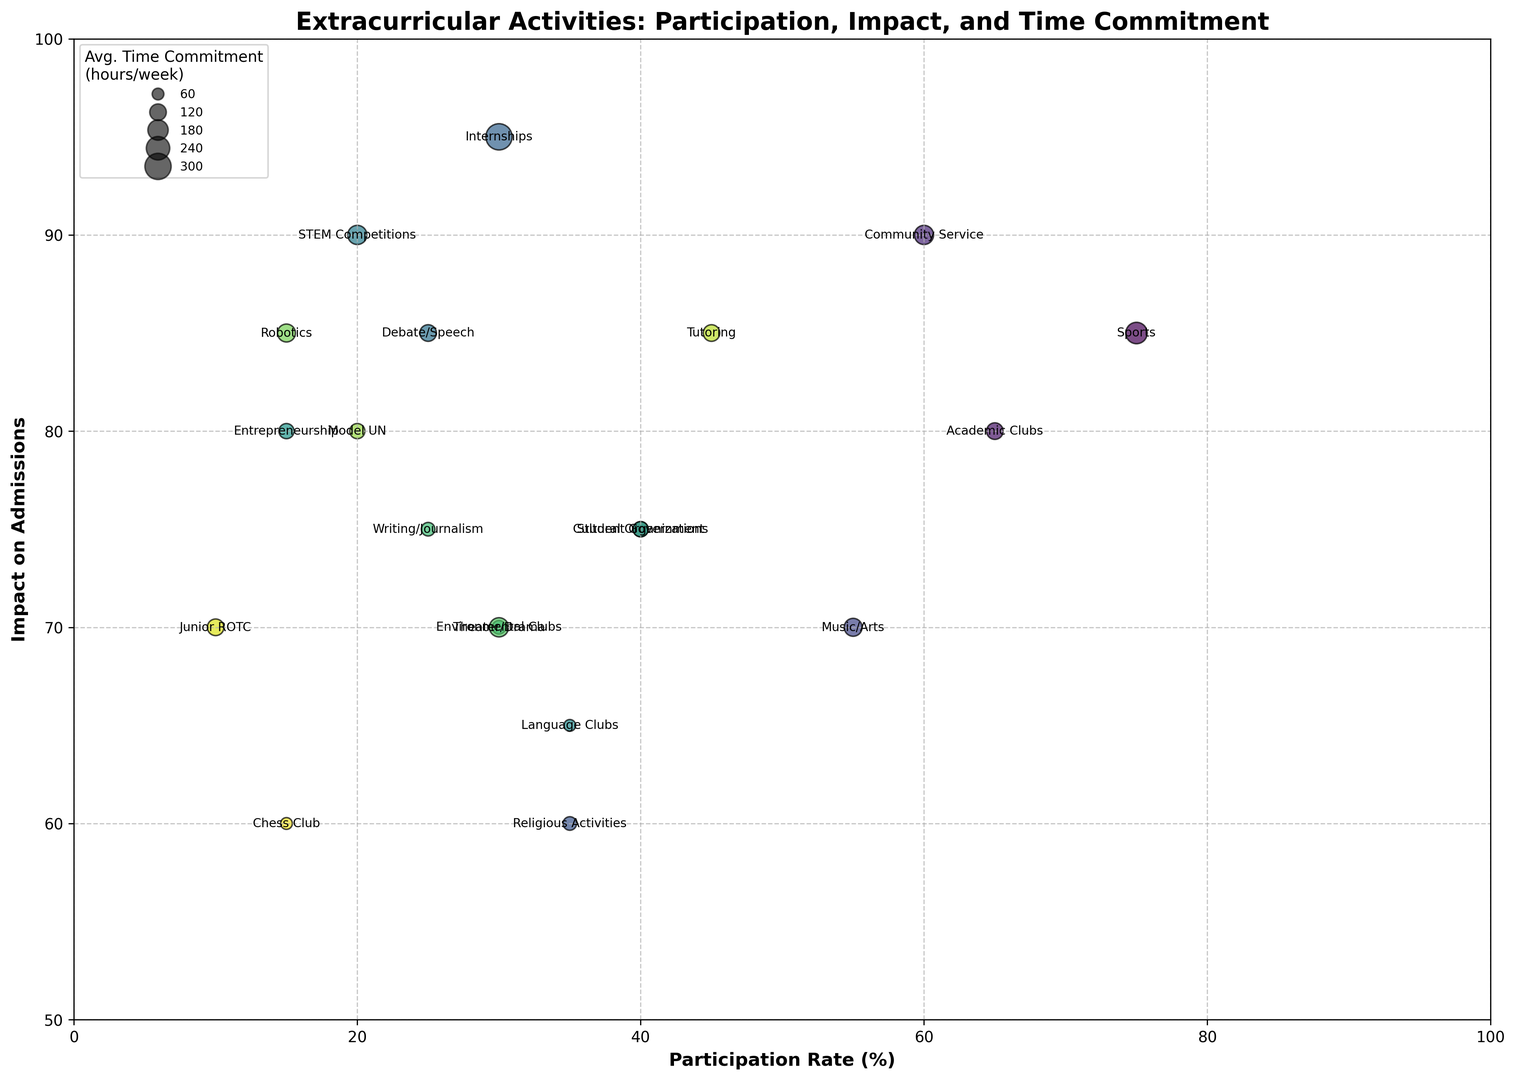What activity has the highest participation rate? The highest participation rate is observed by finding the activity with the largest x-coordinate value on the chart. Sports has the highest participation rate with a value of 75%.
Answer: Sports Which activity has the highest impact on admissions and what is its average time commitment? The activity with the highest impact on admissions can be identified by finding the activity with the largest y-coordinate value. The corresponding bubble size will give the average time commitment. Internships have the highest impact on admissions, with an average time commitment of 15 hours/week.
Answer: Internships, 15 hours/week What is the participation rate percentage difference between Debate/Speech and Robotics? Locate the x-coordinate values for both Debate/Speech and Robotics, subtract the smaller value from the larger one. Debate/Speech has a participation rate of 25% and Robotics has 15%, so the difference is 25 - 15 = 10%.
Answer: 10% Which activities have an impact on admissions of 85 or higher? Identify the activities whose y-coordinate values are 85 or above. The activities that meet this criterion are Sports, Internships, Debate/Speech, Tutoring, and Robotics.
Answer: Sports, Internships, Debate/Speech, Tutoring, Robotics What is the average impact on admissions for Student Government, Music/Arts and Cultural Organizations? Find the y-coordinate values for each of the three activities and calculate their average: (75 + 70 + 75) / 3 = 73.33.
Answer: 73.33 Which activity requires the least time commitment on average, and what is its impact on admissions? Find the smallest bubble size and identify the corresponding activity. Religious Activities has the smallest bubble size, representing the least time commitment with an average of 4 hours/week, and it has an impact on admissions of 60.
Answer: Religious Activities, 60 How does the participation rate of STEM Competitions compare with the participation rate of Junior ROTC? Compare the x-coordinate values of STEM Competitions and Junior ROTC. STEM Competitions has a participation rate of 20% while Junior ROTC has 10%, so STEM Competitions has a higher participation rate.
Answer: STEM Competitions is higher Which activity has a higher impact on admissions: Language Clubs or Environmental Clubs? Compare the y-coordinate values of Language Clubs and Environmental Clubs. Language Clubs have an impact of 65 while Environmental Clubs have an impact of 70, so Environmental Clubs have a higher impact on admissions.
Answer: Environmental Clubs Are there any activities with both a high participation rate (above 50%) and high impact on admissions (above 80%)? Examine the chart for activities with both x-coordinate values above 50 and y-coordinate values above 80. Sports is the only activity that meets both criteria with 75% participation and 85 impact on admissions.
Answer: Sports 